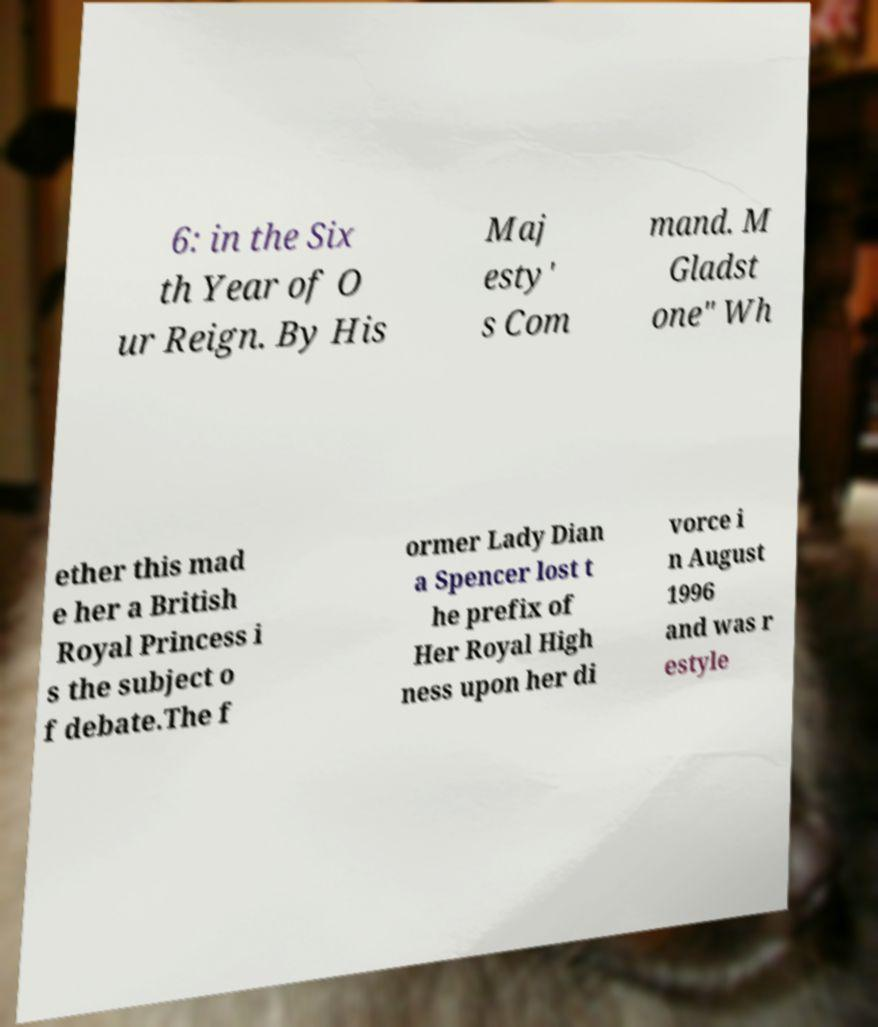Could you extract and type out the text from this image? 6: in the Six th Year of O ur Reign. By His Maj esty' s Com mand. M Gladst one" Wh ether this mad e her a British Royal Princess i s the subject o f debate.The f ormer Lady Dian a Spencer lost t he prefix of Her Royal High ness upon her di vorce i n August 1996 and was r estyle 